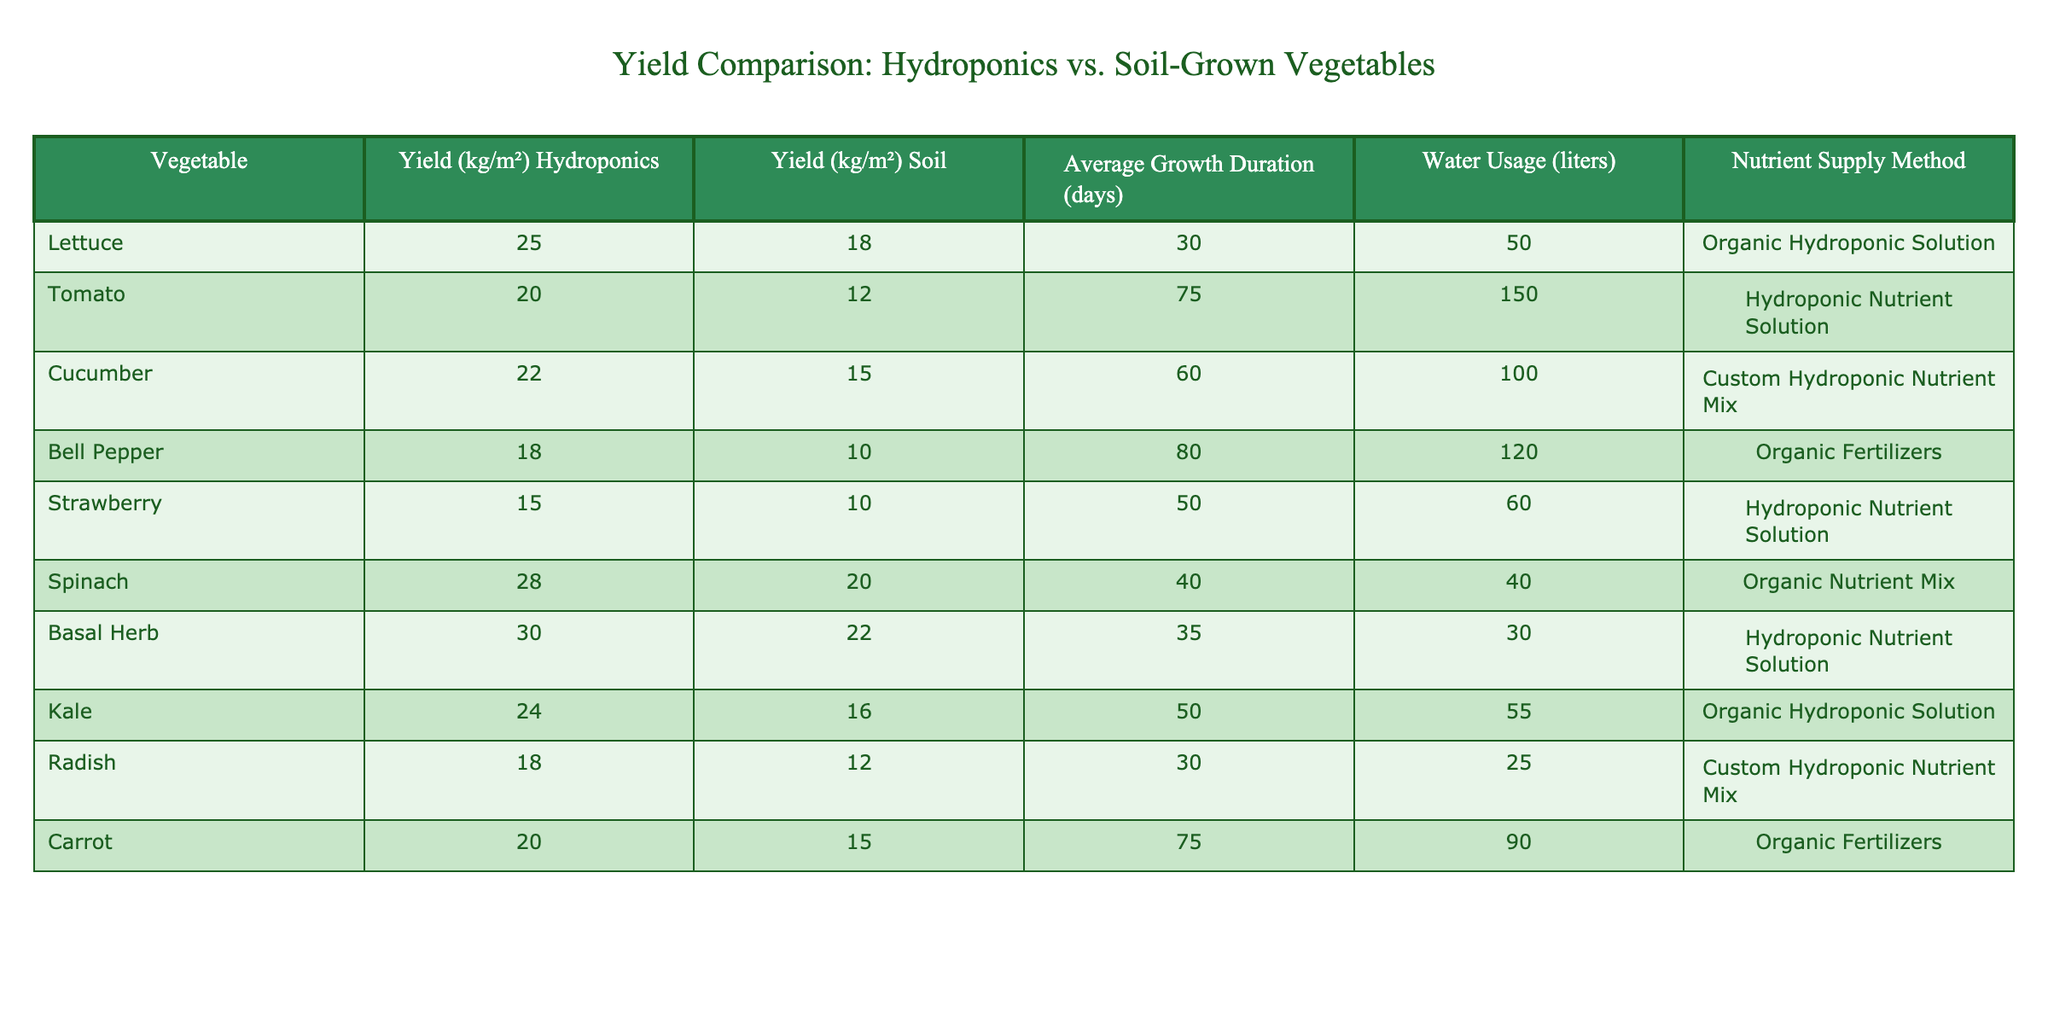What is the yield of hydroponically grown lettuce? The table lists the yield of hydroponically grown lettuce as 25 kg/m².
Answer: 25 kg/m² Which vegetable has the highest yield in soil? By examining the table, the highest yield for soil-grown vegetables is 22 kg/m² for Basal Herb.
Answer: 22 kg/m² What is the average growth duration for tomatoes? According to the table, the average growth duration for tomatoes is 75 days.
Answer: 75 days Compare the water usage of hydroponically grown carrots to soil-grown carrots. Hydroponically grown carrots use 90 liters of water, while soil-grown carrots use 90 liters as well, meaning their water usage is the same.
Answer: Same usage Is the nutrient supply method for cucumbers organic? The table states that cucumbers use a "Custom Hydroponic Nutrient Mix," which is not an organic method.
Answer: No What is the difference in yield between hydroponically grown and soil-grown spinach? Hydroponic spinach yields 28 kg/m² while soil-grown spinach yields 20 kg/m². So, the difference is 28 - 20 = 8 kg/m².
Answer: 8 kg/m² Which vegetable has the highest water usage, and what is the amount? The highest water usage is attributed to tomatoes, which use 150 liters of water.
Answer: 150 liters What is the average yield of hydroponically grown vegetables in the table? The hydroponic yields listed are: 25, 20, 22, 18, 15, 28, 30, 24, 18, 20. Adding these gives 25 + 20 + 22 + 18 + 15 + 28 + 30 + 24 + 18 + 20 =  208 kg/m². There are 10 vegetables, so the average yield is 208/10 = 20.8 kg/m².
Answer: 20.8 kg/m² How does the yield of hydroponically grown basal herb compare to that of bell peppers? Hydroponically grown basal herb yields 30 kg/m², whereas bell peppers yield 18 kg/m². The difference in yield is 30 - 18 = 12 kg/m², indicating a higher yield for basal herb.
Answer: 12 kg/m² more Which vegetable has the lowest yield when grown in soil? The table shows that both strawberries and bell peppers have the lowest yield at 10 kg/m² when grown in soil.
Answer: 10 kg/m² 